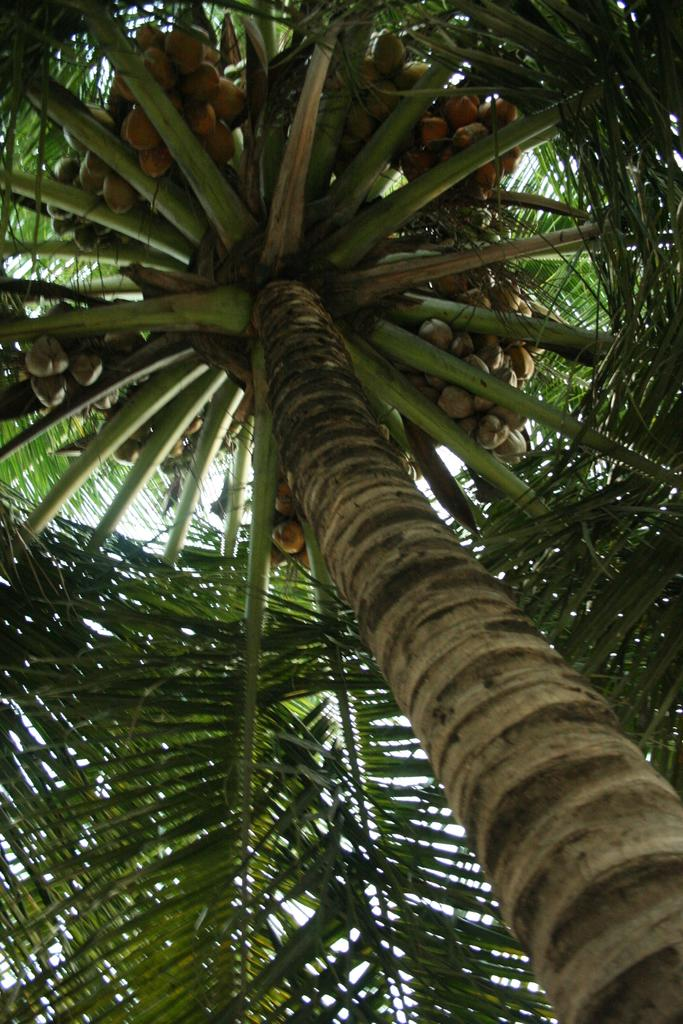What type of tree is in the picture? There is a coconut tree in the picture. What can be seen on the tree? Coconuts are visible on the tree. What is visible in the background of the picture? The sky is visible in the background of the picture. What type of pot is hanging from the coconut tree in the image? There is no pot hanging from the coconut tree in the image. 